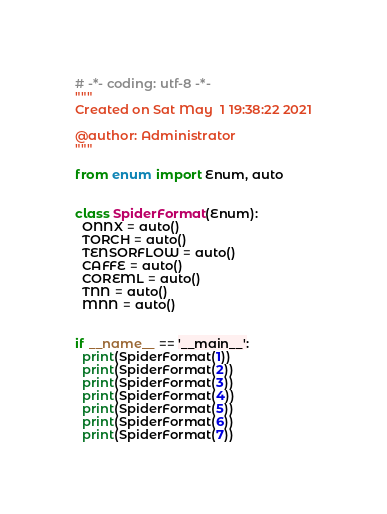<code> <loc_0><loc_0><loc_500><loc_500><_Python_># -*- coding: utf-8 -*-
"""
Created on Sat May  1 19:38:22 2021

@author: Administrator
"""

from enum import Enum, auto


class SpiderFormat(Enum):
  ONNX = auto()
  TORCH = auto()
  TENSORFLOW = auto()
  CAFFE = auto()
  COREML = auto()
  TNN = auto()
  MNN = auto()


if __name__ == '__main__':
  print(SpiderFormat(1))
  print(SpiderFormat(2))
  print(SpiderFormat(3))
  print(SpiderFormat(4))
  print(SpiderFormat(5))
  print(SpiderFormat(6))
  print(SpiderFormat(7))
</code> 